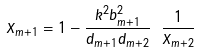<formula> <loc_0><loc_0><loc_500><loc_500>X _ { m + 1 } = 1 - { \frac { k ^ { 2 } b _ { m + 1 } ^ { 2 } } { d _ { m + 1 } d _ { m + 2 } } } \ { \frac { 1 } { X _ { m + 2 } } }</formula> 